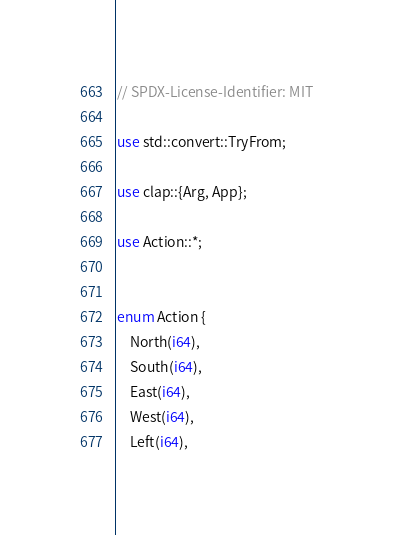<code> <loc_0><loc_0><loc_500><loc_500><_Rust_>// SPDX-License-Identifier: MIT

use std::convert::TryFrom;

use clap::{Arg, App};

use Action::*;


enum Action {
    North(i64),
    South(i64),
    East(i64),
    West(i64),
    Left(i64),</code> 